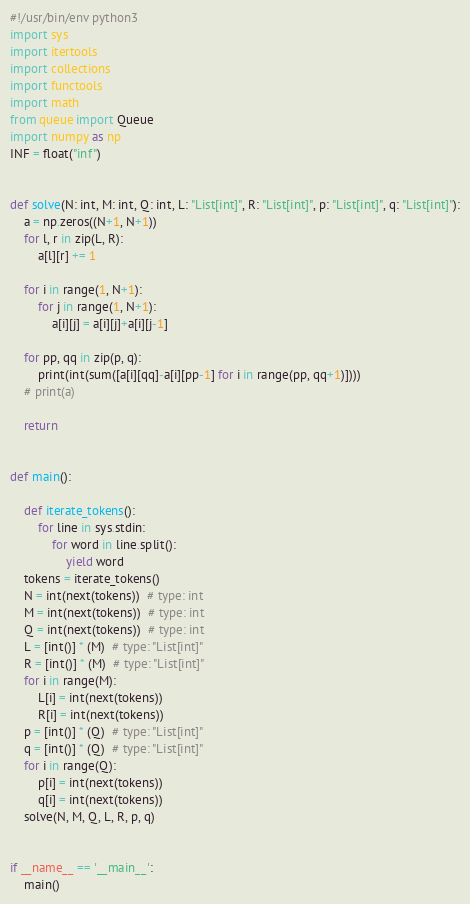<code> <loc_0><loc_0><loc_500><loc_500><_Python_>#!/usr/bin/env python3
import sys
import itertools
import collections
import functools
import math
from queue import Queue
import numpy as np
INF = float("inf")


def solve(N: int, M: int, Q: int, L: "List[int]", R: "List[int]", p: "List[int]", q: "List[int]"):
    a = np.zeros((N+1, N+1))
    for l, r in zip(L, R):
        a[l][r] += 1

    for i in range(1, N+1):
        for j in range(1, N+1):
            a[i][j] = a[i][j]+a[i][j-1]

    for pp, qq in zip(p, q):
        print(int(sum([a[i][qq]-a[i][pp-1] for i in range(pp, qq+1)])))
    # print(a)

    return


def main():

    def iterate_tokens():
        for line in sys.stdin:
            for word in line.split():
                yield word
    tokens = iterate_tokens()
    N = int(next(tokens))  # type: int
    M = int(next(tokens))  # type: int
    Q = int(next(tokens))  # type: int
    L = [int()] * (M)  # type: "List[int]"
    R = [int()] * (M)  # type: "List[int]"
    for i in range(M):
        L[i] = int(next(tokens))
        R[i] = int(next(tokens))
    p = [int()] * (Q)  # type: "List[int]"
    q = [int()] * (Q)  # type: "List[int]"
    for i in range(Q):
        p[i] = int(next(tokens))
        q[i] = int(next(tokens))
    solve(N, M, Q, L, R, p, q)


if __name__ == '__main__':
    main()
</code> 